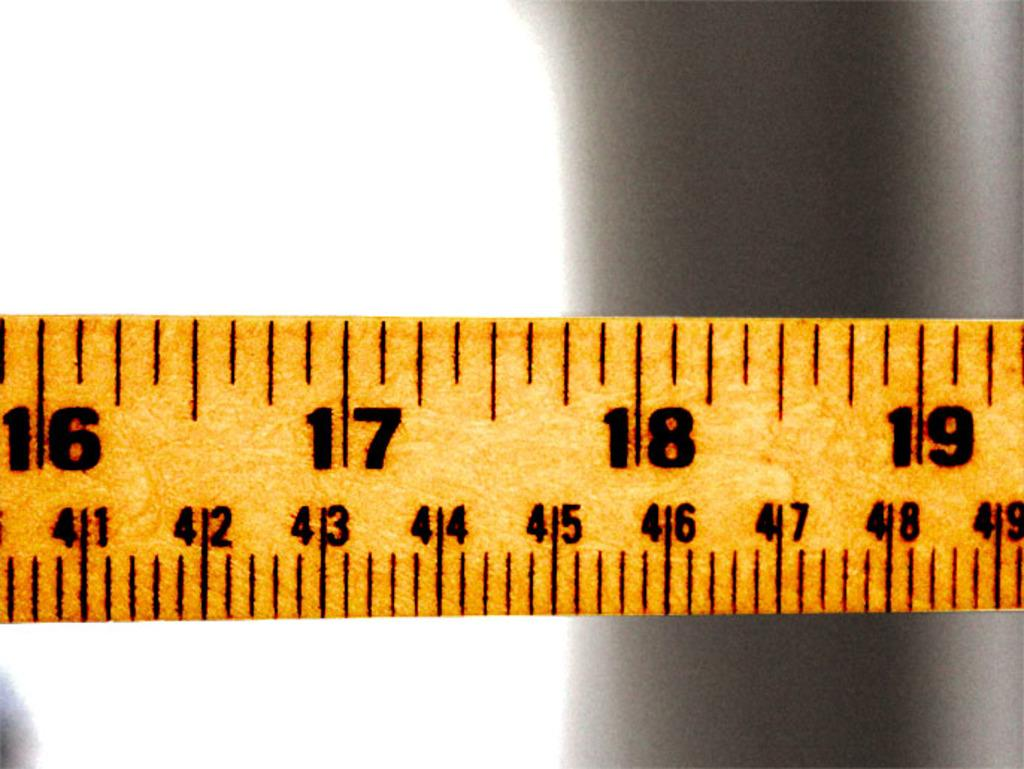<image>
Give a short and clear explanation of the subsequent image. A yellow tape measure showing sixteen through nineteen. 